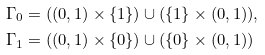<formula> <loc_0><loc_0><loc_500><loc_500>& \Gamma _ { 0 } = ( ( 0 , 1 ) \times \{ 1 \} ) \cup ( \{ 1 \} \times ( 0 , 1 ) ) , \\ & \Gamma _ { 1 } = ( ( 0 , 1 ) \times \{ 0 \} ) \cup ( \{ 0 \} \times ( 0 , 1 ) )</formula> 